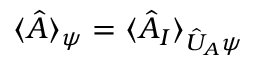Convert formula to latex. <formula><loc_0><loc_0><loc_500><loc_500>\langle \hat { A } \rangle _ { \psi } = \langle \hat { A } _ { I } \rangle _ { \hat { U } _ { A } \psi }</formula> 